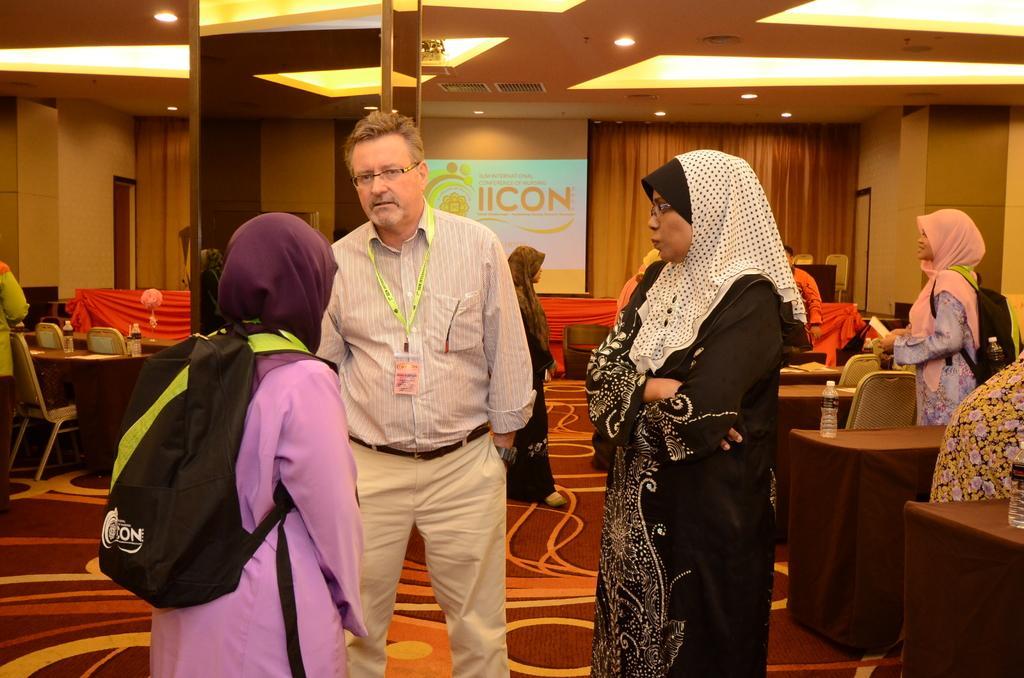Can you describe this image briefly? In this image, we can see a man wearing an id card and there are some ladies standing and wearing bags. In the background, we can see tables and chairs and projector screen. At the top,there is roof. 